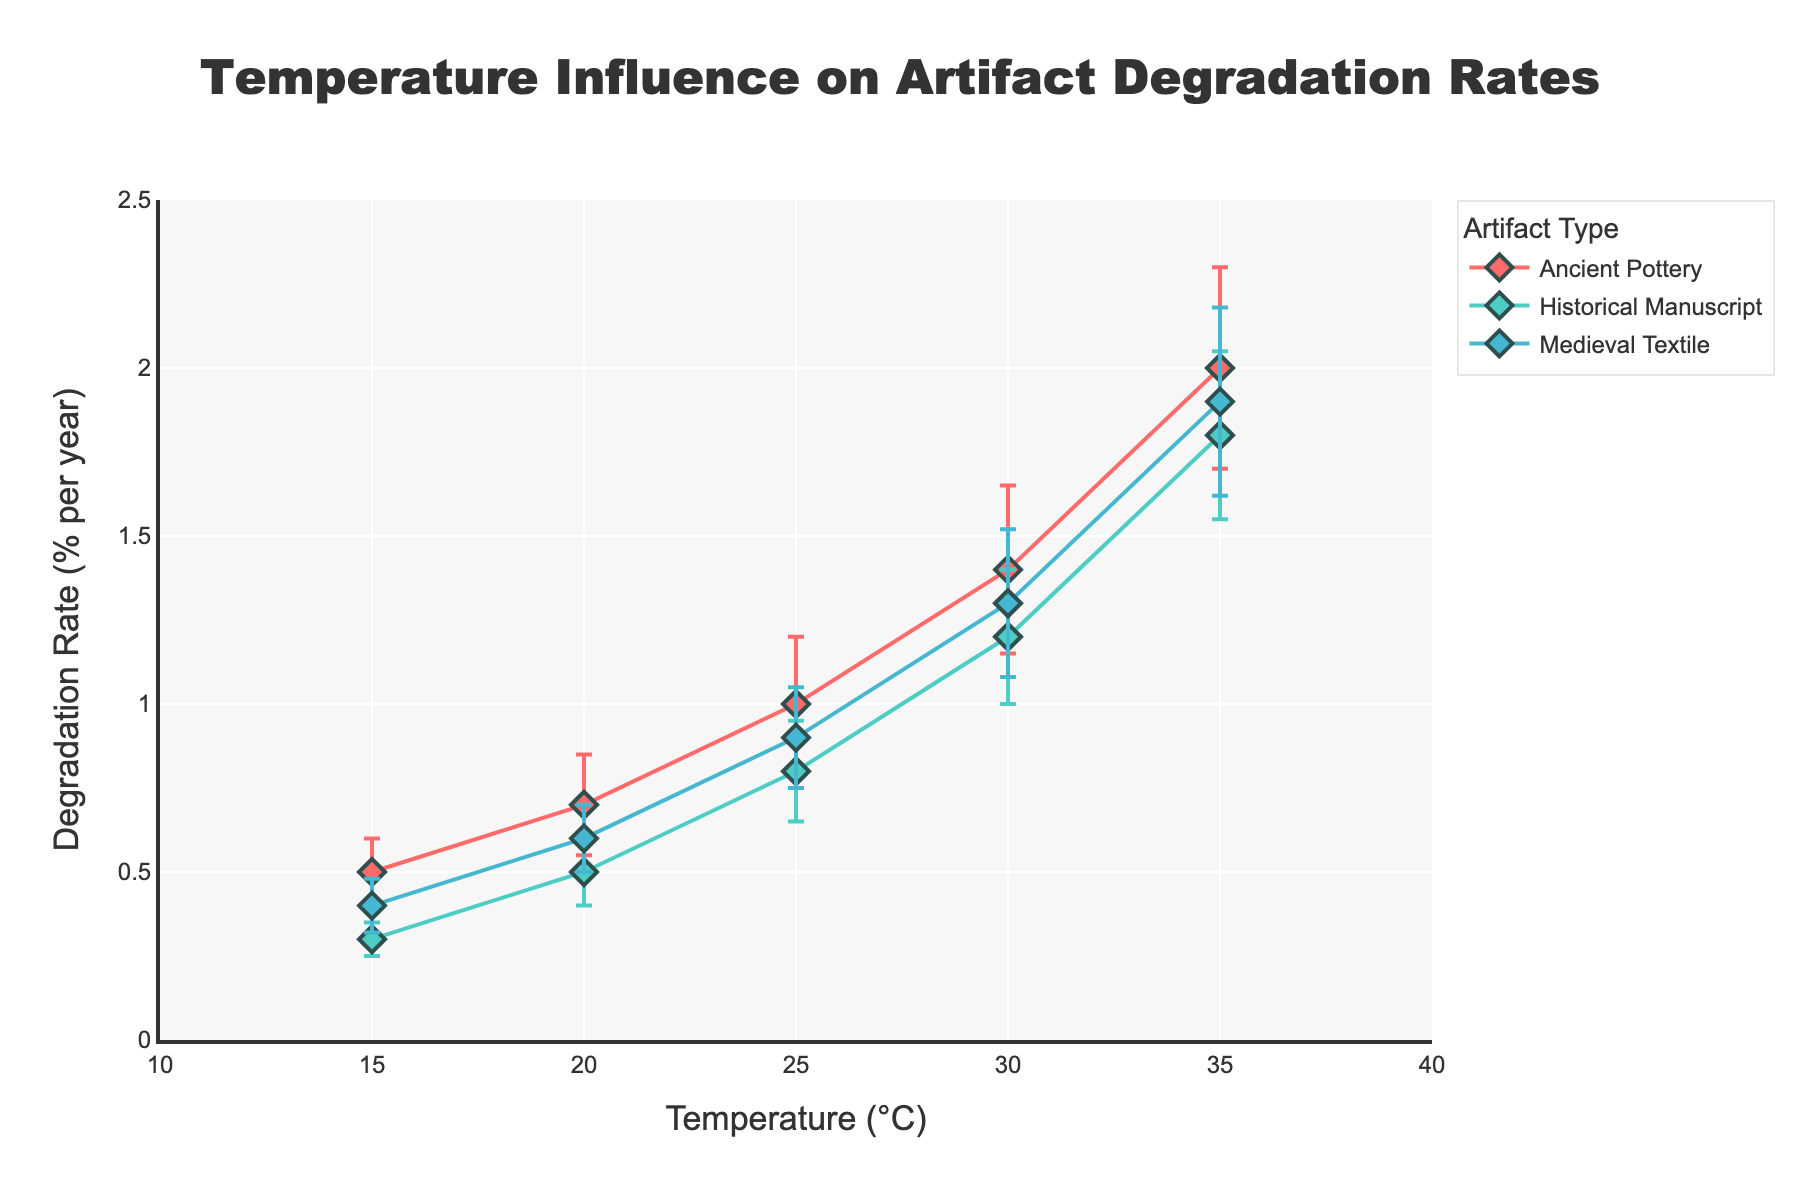What's the title of the figure? The title of the figure is displayed prominently at the top center. It reads: "Temperature Influence on Artifact Degradation Rates".
Answer: Temperature Influence on Artifact Degradation Rates What is the degradation rate of Ancient Pottery at 30°C? Look at the data point for Ancient Pottery where the x-axis (Temperature) is 30°C and read the corresponding y-axis value, which indicates the Degradation Rate.
Answer: 1.4% per year Which artifact shows the highest degradation rate at 35°C? Compare the degradation rates of all artifacts at 35°C. Ancient Pottery shows the highest rate.
Answer: Ancient Pottery What is the average degradation rate for Historical Manuscript from 15°C to 35°C? Identify all degradation rates for Historical Manuscript and compute their average: (0.3 + 0.5 + 0.8 + 1.2 + 1.8) / 5.
Answer: 0.92% per year Which artifact has the smallest error bar at 15°C and what is its value? Look at the error bars for all artifacts at 15°C and find the smallest one, which belongs to Historical Manuscript with an error of 0.05%.
Answer: Historical Manuscript, 0.05% How does the degradation rate change for Ancient Pottery from 20°C to 25°C? Look at the degradation rates for Ancient Pottery at 20°C (0.7%) and 25°C (1.0%) and calculate the difference.
Answer: It increases by 0.3% per year What range is used for the x-axis (Temperature)? The range for the x-axis (Temperature) is shown between 10°C and 40°C.
Answer: 10°C to 40°C Is there any artifact where the degradation rate is linearly proportional to temperature? Examine if any artifact’s degradation rates form a straight line. For Historical Manuscript, the rates increase almost linearly with temperature.
Answer: Historical Manuscript 